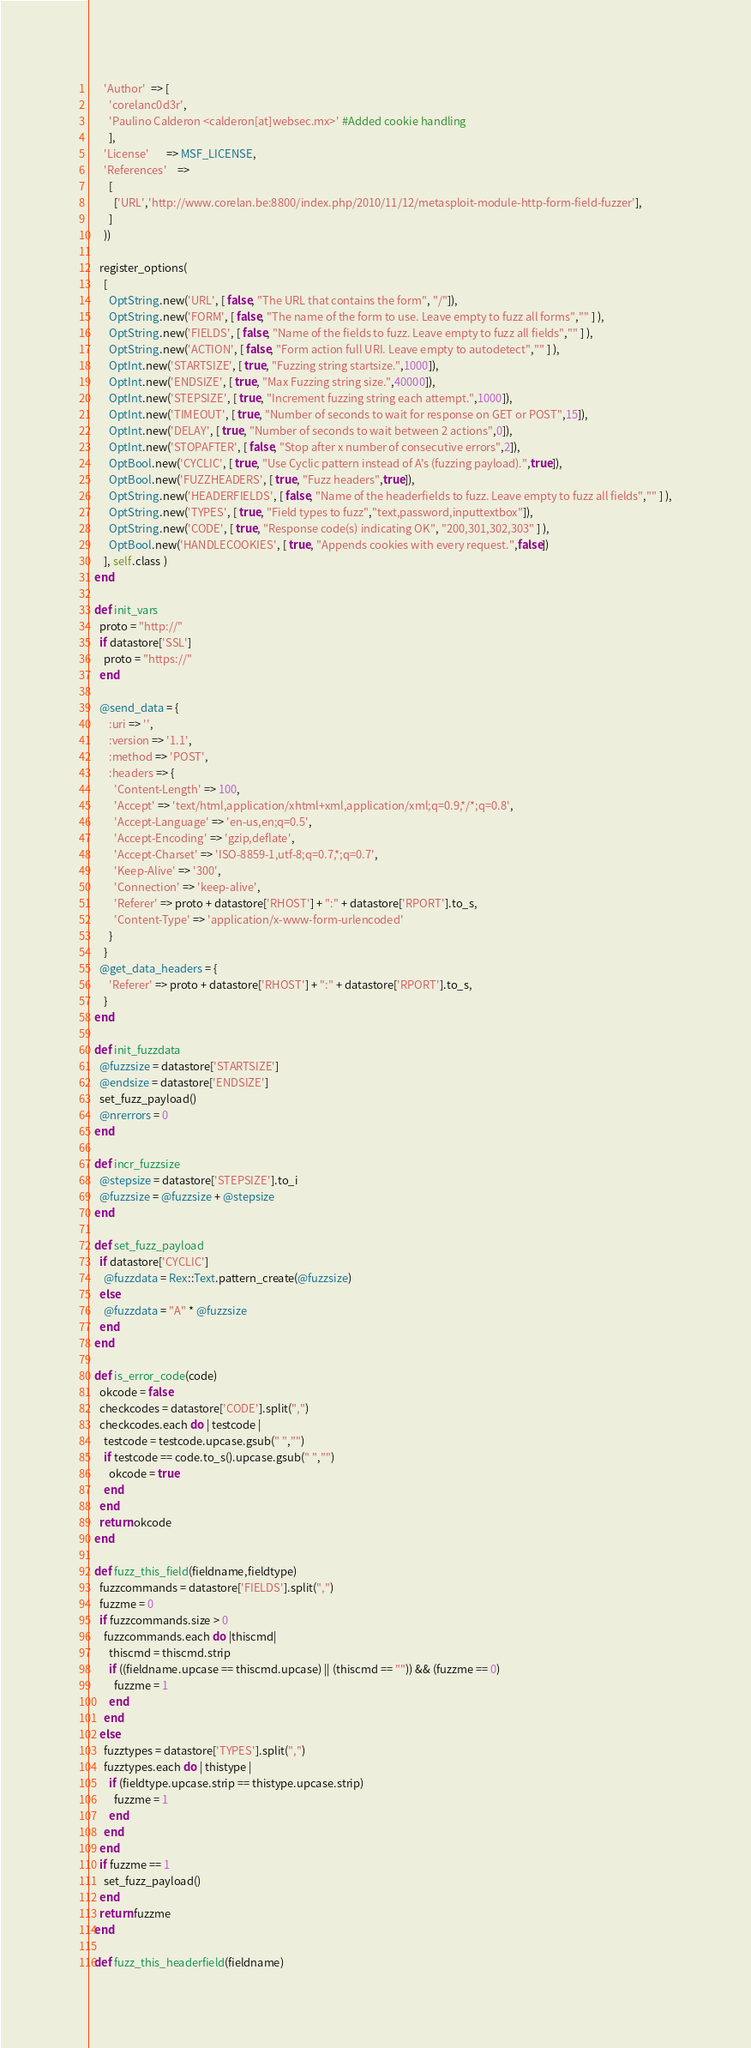<code> <loc_0><loc_0><loc_500><loc_500><_Ruby_>      'Author'  => [
        'corelanc0d3r',
        'Paulino Calderon <calderon[at]websec.mx>' #Added cookie handling
        ],
      'License'       => MSF_LICENSE,
      'References'    =>
        [
          ['URL','http://www.corelan.be:8800/index.php/2010/11/12/metasploit-module-http-form-field-fuzzer'],
        ]
      ))

    register_options(
      [
        OptString.new('URL', [ false, "The URL that contains the form", "/"]),
        OptString.new('FORM', [ false, "The name of the form to use. Leave empty to fuzz all forms","" ] ),
        OptString.new('FIELDS', [ false, "Name of the fields to fuzz. Leave empty to fuzz all fields","" ] ),
        OptString.new('ACTION', [ false, "Form action full URI. Leave empty to autodetect","" ] ),
        OptInt.new('STARTSIZE', [ true, "Fuzzing string startsize.",1000]),
        OptInt.new('ENDSIZE', [ true, "Max Fuzzing string size.",40000]),
        OptInt.new('STEPSIZE', [ true, "Increment fuzzing string each attempt.",1000]),
        OptInt.new('TIMEOUT', [ true, "Number of seconds to wait for response on GET or POST",15]),
        OptInt.new('DELAY', [ true, "Number of seconds to wait between 2 actions",0]),
        OptInt.new('STOPAFTER', [ false, "Stop after x number of consecutive errors",2]),
        OptBool.new('CYCLIC', [ true, "Use Cyclic pattern instead of A's (fuzzing payload).",true]),
        OptBool.new('FUZZHEADERS', [ true, "Fuzz headers",true]),
        OptString.new('HEADERFIELDS', [ false, "Name of the headerfields to fuzz. Leave empty to fuzz all fields","" ] ),
        OptString.new('TYPES', [ true, "Field types to fuzz","text,password,inputtextbox"]),
        OptString.new('CODE', [ true, "Response code(s) indicating OK", "200,301,302,303" ] ),
        OptBool.new('HANDLECOOKIES', [ true, "Appends cookies with every request.",false])
      ], self.class )
  end

  def init_vars
    proto = "http://"
    if datastore['SSL']
      proto = "https://"
    end

    @send_data = {
        :uri => '',
        :version => '1.1',
        :method => 'POST',
        :headers => {
          'Content-Length' => 100,
          'Accept' => 'text/html,application/xhtml+xml,application/xml;q=0.9,*/*;q=0.8',
          'Accept-Language' => 'en-us,en;q=0.5',
          'Accept-Encoding' => 'gzip,deflate',
          'Accept-Charset' => 'ISO-8859-1,utf-8;q=0.7,*;q=0.7',
          'Keep-Alive' => '300',
          'Connection' => 'keep-alive',
          'Referer' => proto + datastore['RHOST'] + ":" + datastore['RPORT'].to_s,
          'Content-Type' => 'application/x-www-form-urlencoded'
        }
      }
    @get_data_headers = {
        'Referer' => proto + datastore['RHOST'] + ":" + datastore['RPORT'].to_s,
      }
  end

  def init_fuzzdata
    @fuzzsize = datastore['STARTSIZE']
    @endsize = datastore['ENDSIZE']
    set_fuzz_payload()
    @nrerrors = 0
  end

  def incr_fuzzsize
    @stepsize = datastore['STEPSIZE'].to_i
    @fuzzsize = @fuzzsize + @stepsize
  end

  def set_fuzz_payload
    if datastore['CYCLIC']
      @fuzzdata = Rex::Text.pattern_create(@fuzzsize)
    else
      @fuzzdata = "A" * @fuzzsize
    end
  end

  def is_error_code(code)
    okcode = false
    checkcodes = datastore['CODE'].split(",")
    checkcodes.each do | testcode |
      testcode = testcode.upcase.gsub(" ","")
      if testcode == code.to_s().upcase.gsub(" ","")
        okcode = true
      end
    end
    return okcode
  end

  def fuzz_this_field(fieldname,fieldtype)
    fuzzcommands = datastore['FIELDS'].split(",")
    fuzzme = 0
    if fuzzcommands.size > 0
      fuzzcommands.each do |thiscmd|
        thiscmd = thiscmd.strip
        if ((fieldname.upcase == thiscmd.upcase) || (thiscmd == "")) && (fuzzme == 0)
          fuzzme = 1
        end
      end
    else
      fuzztypes = datastore['TYPES'].split(",")
      fuzztypes.each do | thistype |
        if (fieldtype.upcase.strip == thistype.upcase.strip)
          fuzzme = 1
        end
      end
    end
    if fuzzme == 1
      set_fuzz_payload()
    end
    return fuzzme
  end

  def fuzz_this_headerfield(fieldname)</code> 